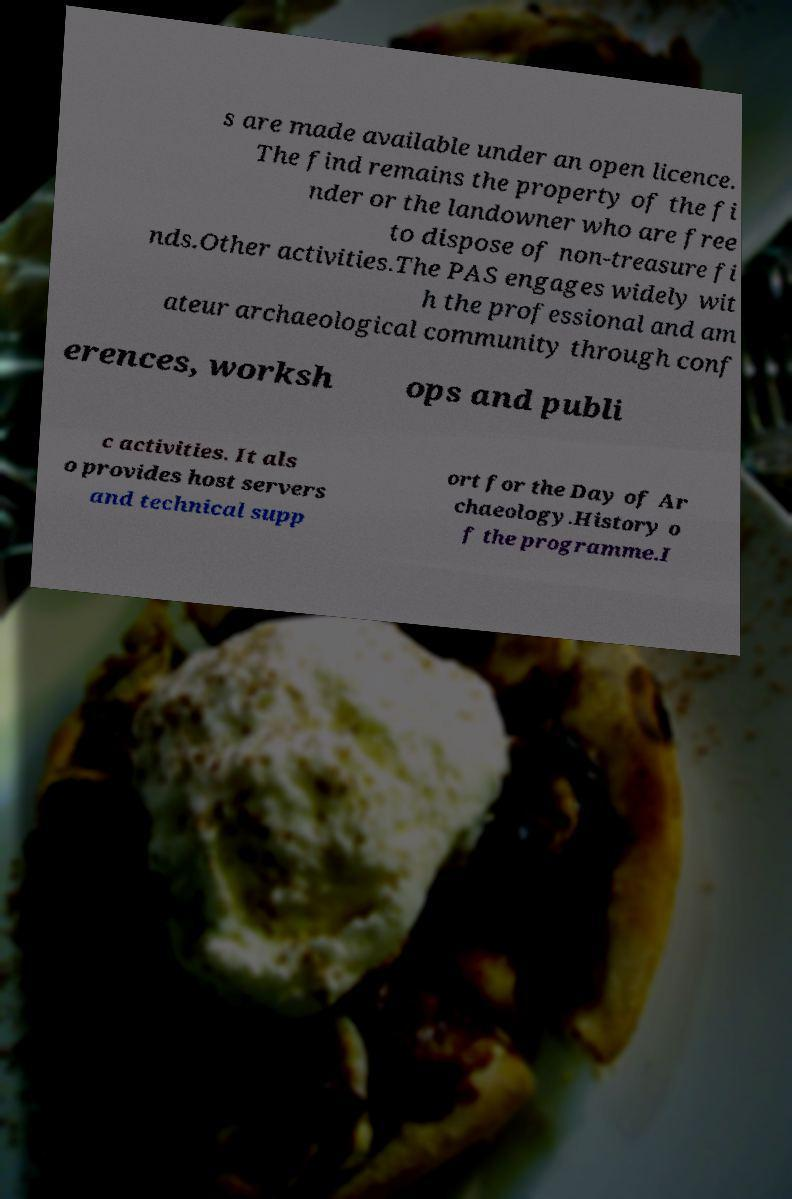What messages or text are displayed in this image? I need them in a readable, typed format. s are made available under an open licence. The find remains the property of the fi nder or the landowner who are free to dispose of non-treasure fi nds.Other activities.The PAS engages widely wit h the professional and am ateur archaeological community through conf erences, worksh ops and publi c activities. It als o provides host servers and technical supp ort for the Day of Ar chaeology.History o f the programme.I 